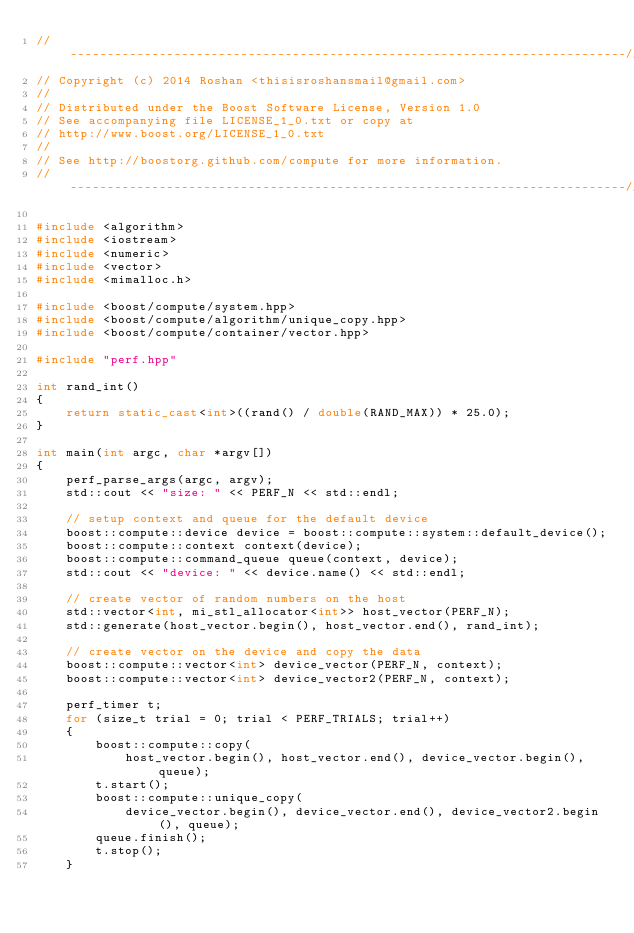<code> <loc_0><loc_0><loc_500><loc_500><_C++_>//---------------------------------------------------------------------------//
// Copyright (c) 2014 Roshan <thisisroshansmail@gmail.com>
//
// Distributed under the Boost Software License, Version 1.0
// See accompanying file LICENSE_1_0.txt or copy at
// http://www.boost.org/LICENSE_1_0.txt
//
// See http://boostorg.github.com/compute for more information.
//---------------------------------------------------------------------------//

#include <algorithm>
#include <iostream>
#include <numeric>
#include <vector>
#include <mimalloc.h>

#include <boost/compute/system.hpp>
#include <boost/compute/algorithm/unique_copy.hpp>
#include <boost/compute/container/vector.hpp>

#include "perf.hpp"

int rand_int()
{
    return static_cast<int>((rand() / double(RAND_MAX)) * 25.0);
}

int main(int argc, char *argv[])
{
    perf_parse_args(argc, argv);
    std::cout << "size: " << PERF_N << std::endl;

    // setup context and queue for the default device
    boost::compute::device device = boost::compute::system::default_device();
    boost::compute::context context(device);
    boost::compute::command_queue queue(context, device);
    std::cout << "device: " << device.name() << std::endl;

    // create vector of random numbers on the host
    std::vector<int, mi_stl_allocator<int>> host_vector(PERF_N);
    std::generate(host_vector.begin(), host_vector.end(), rand_int);

    // create vector on the device and copy the data
    boost::compute::vector<int> device_vector(PERF_N, context);
    boost::compute::vector<int> device_vector2(PERF_N, context);

    perf_timer t;
    for (size_t trial = 0; trial < PERF_TRIALS; trial++)
    {
        boost::compute::copy(
            host_vector.begin(), host_vector.end(), device_vector.begin(), queue);
        t.start();
        boost::compute::unique_copy(
            device_vector.begin(), device_vector.end(), device_vector2.begin(), queue);
        queue.finish();
        t.stop();
    }</code> 